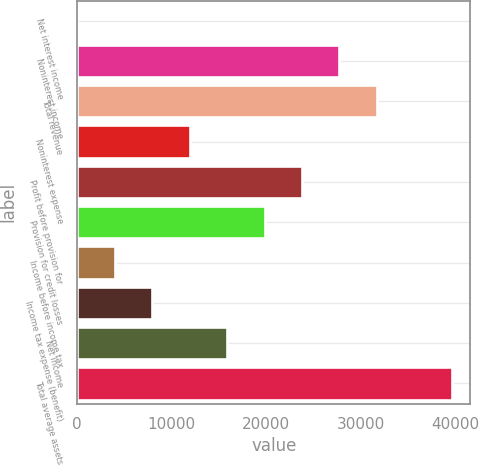Convert chart. <chart><loc_0><loc_0><loc_500><loc_500><bar_chart><fcel>Net interest income<fcel>Noninterest income<fcel>Total revenue<fcel>Noninterest expense<fcel>Profit before provision for<fcel>Provision for credit losses<fcel>Income before income tax<fcel>Income tax expense (benefit)<fcel>Net income<fcel>Total average assets<nl><fcel>27<fcel>27753.3<fcel>31714.2<fcel>11909.7<fcel>23792.4<fcel>19831.5<fcel>3987.9<fcel>7948.8<fcel>15870.6<fcel>39636<nl></chart> 